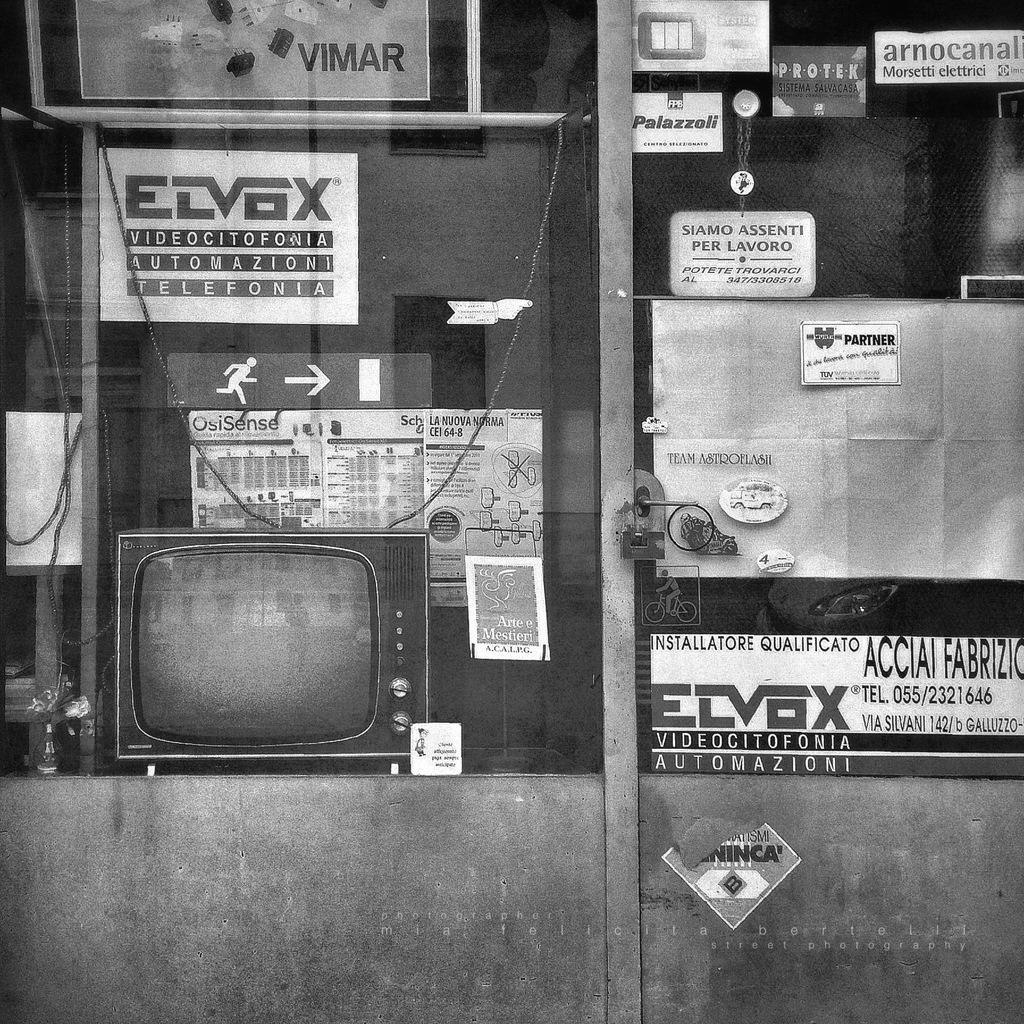<image>
Create a compact narrative representing the image presented. a window display including an old TV and a sign saying Automazioni 